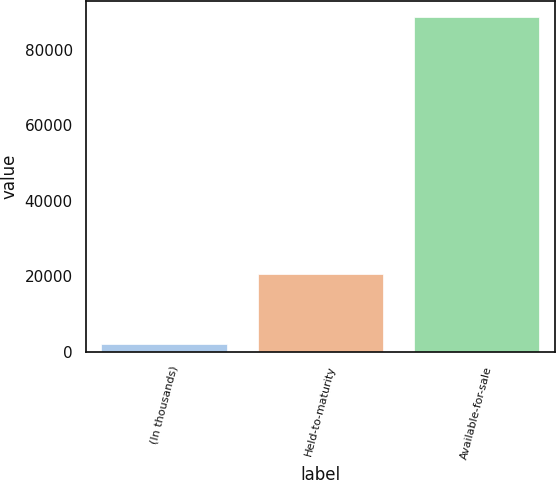Convert chart. <chart><loc_0><loc_0><loc_500><loc_500><bar_chart><fcel>(In thousands)<fcel>Held-to-maturity<fcel>Available-for-sale<nl><fcel>2012<fcel>20699<fcel>88698<nl></chart> 